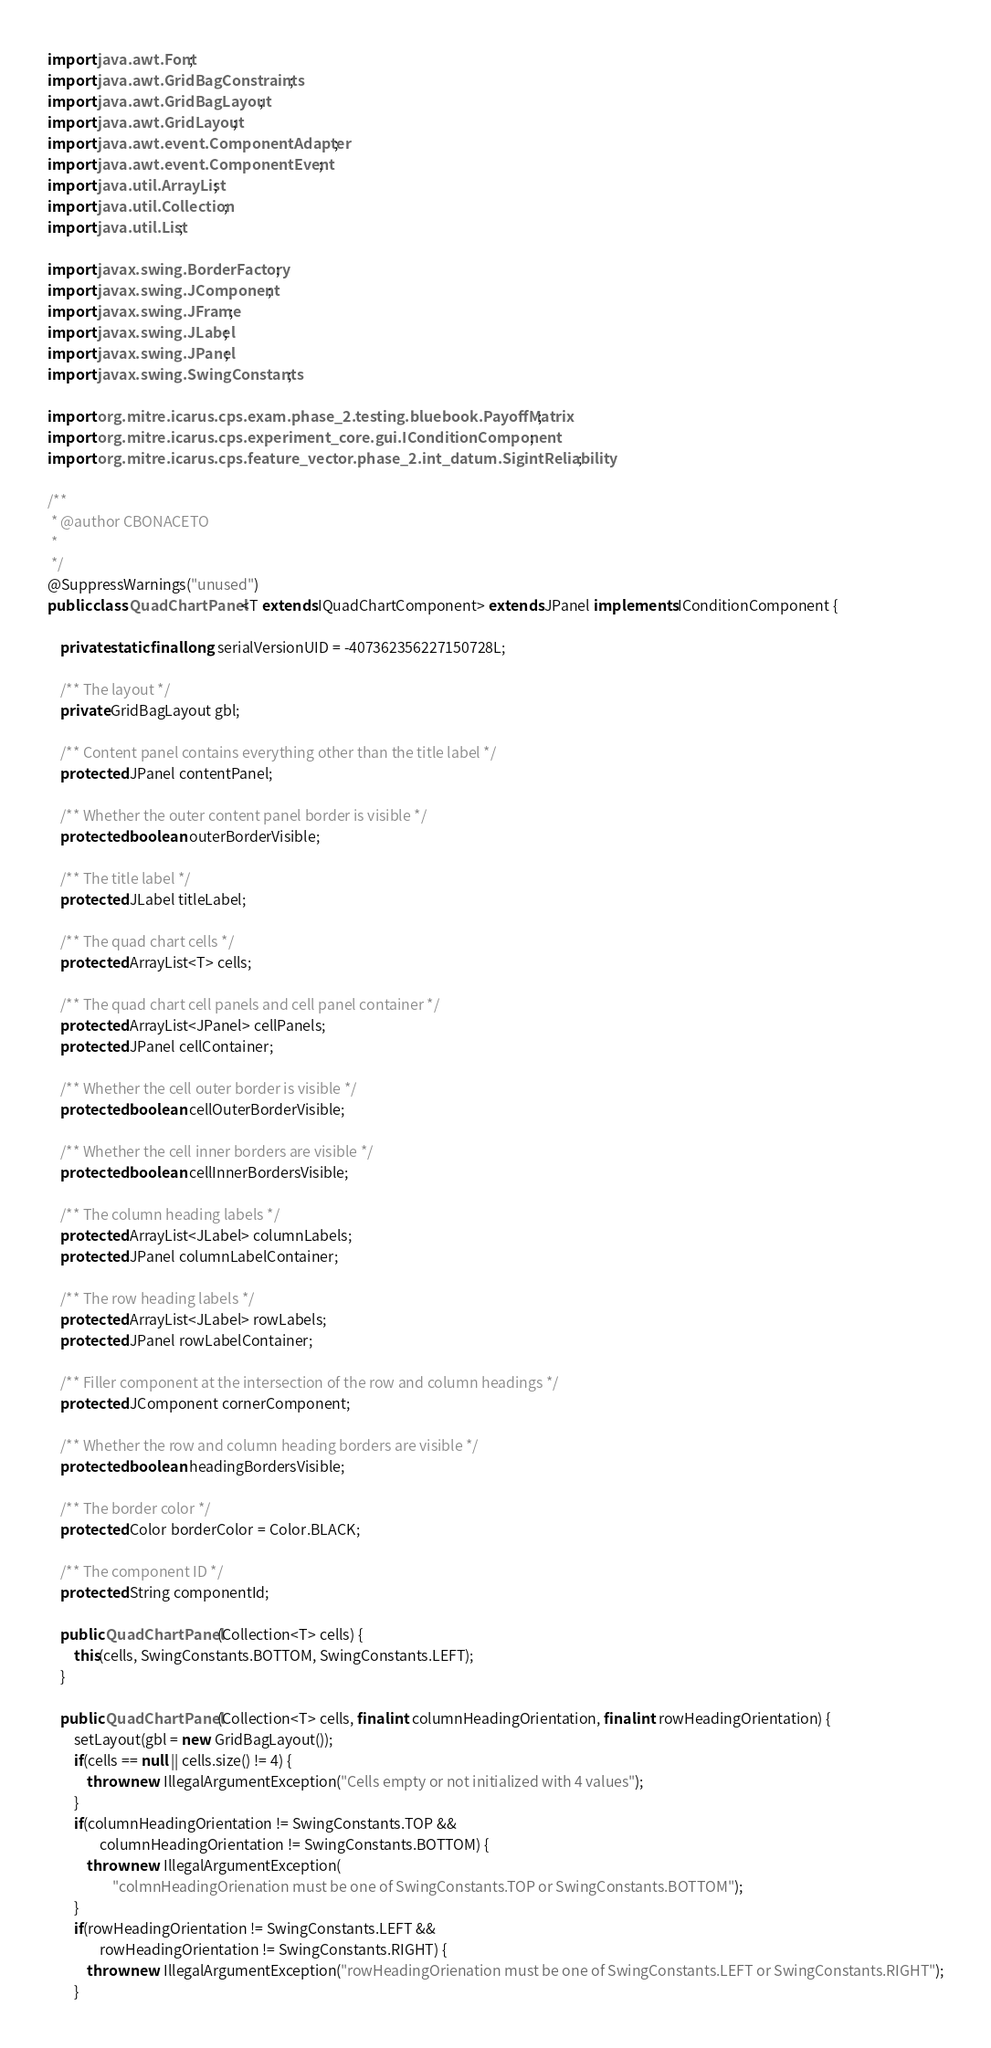Convert code to text. <code><loc_0><loc_0><loc_500><loc_500><_Java_>import java.awt.Font;
import java.awt.GridBagConstraints;
import java.awt.GridBagLayout;
import java.awt.GridLayout;
import java.awt.event.ComponentAdapter;
import java.awt.event.ComponentEvent;
import java.util.ArrayList;
import java.util.Collection;
import java.util.List;

import javax.swing.BorderFactory;
import javax.swing.JComponent;
import javax.swing.JFrame;
import javax.swing.JLabel;
import javax.swing.JPanel;
import javax.swing.SwingConstants;

import org.mitre.icarus.cps.exam.phase_2.testing.bluebook.PayoffMatrix;
import org.mitre.icarus.cps.experiment_core.gui.IConditionComponent;
import org.mitre.icarus.cps.feature_vector.phase_2.int_datum.SigintReliability;

/**
 * @author CBONACETO
 *
 */
@SuppressWarnings("unused")
public class QuadChartPanel<T extends IQuadChartComponent> extends JPanel implements IConditionComponent {

	private static final long serialVersionUID = -407362356227150728L;
	
	/** The layout */
	private GridBagLayout gbl;
	
	/** Content panel contains everything other than the title label */
	protected JPanel contentPanel;
	
	/** Whether the outer content panel border is visible */
	protected boolean outerBorderVisible;
	
	/** The title label */
	protected JLabel titleLabel;

	/** The quad chart cells */
	protected ArrayList<T> cells;
	
	/** The quad chart cell panels and cell panel container */
	protected ArrayList<JPanel> cellPanels;
	protected JPanel cellContainer;
	
	/** Whether the cell outer border is visible */
	protected boolean cellOuterBorderVisible;
	
	/** Whether the cell inner borders are visible */
	protected boolean cellInnerBordersVisible;	
	
	/** The column heading labels */
	protected ArrayList<JLabel> columnLabels;
	protected JPanel columnLabelContainer;	
	
	/** The row heading labels */
	protected ArrayList<JLabel> rowLabels;
	protected JPanel rowLabelContainer;
	
	/** Filler component at the intersection of the row and column headings */
	protected JComponent cornerComponent;
	
	/** Whether the row and column heading borders are visible */
	protected boolean headingBordersVisible;	
	
	/** The border color */
	protected Color borderColor = Color.BLACK;
	
	/** The component ID */
	protected String componentId;
	
	public QuadChartPanel(Collection<T> cells) {
		this(cells, SwingConstants.BOTTOM, SwingConstants.LEFT);
	}
	
	public QuadChartPanel(Collection<T> cells, final int columnHeadingOrientation, final int rowHeadingOrientation) {
		setLayout(gbl = new GridBagLayout());
		if(cells == null || cells.size() != 4) {
			throw new IllegalArgumentException("Cells empty or not initialized with 4 values");
		}
		if(columnHeadingOrientation != SwingConstants.TOP && 
				columnHeadingOrientation != SwingConstants.BOTTOM) {
			throw new IllegalArgumentException(
					"colmnHeadingOrienation must be one of SwingConstants.TOP or SwingConstants.BOTTOM");
		}
		if(rowHeadingOrientation != SwingConstants.LEFT && 
				rowHeadingOrientation != SwingConstants.RIGHT) {
			throw new IllegalArgumentException("rowHeadingOrienation must be one of SwingConstants.LEFT or SwingConstants.RIGHT");
		}</code> 